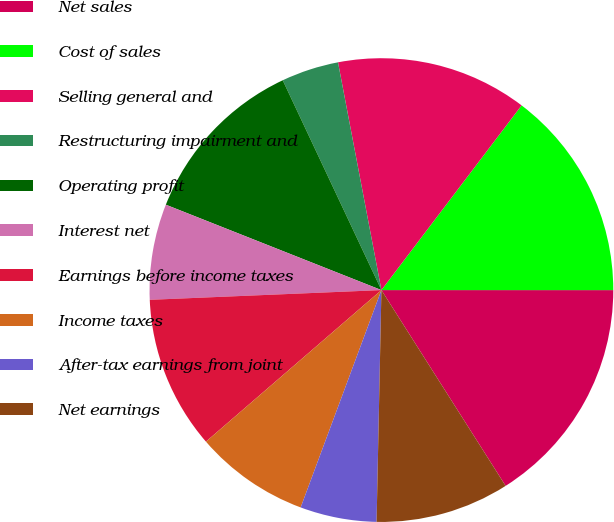<chart> <loc_0><loc_0><loc_500><loc_500><pie_chart><fcel>Net sales<fcel>Cost of sales<fcel>Selling general and<fcel>Restructuring impairment and<fcel>Operating profit<fcel>Interest net<fcel>Earnings before income taxes<fcel>Income taxes<fcel>After-tax earnings from joint<fcel>Net earnings<nl><fcel>16.0%<fcel>14.67%<fcel>13.33%<fcel>4.0%<fcel>12.0%<fcel>6.67%<fcel>10.67%<fcel>8.0%<fcel>5.33%<fcel>9.33%<nl></chart> 